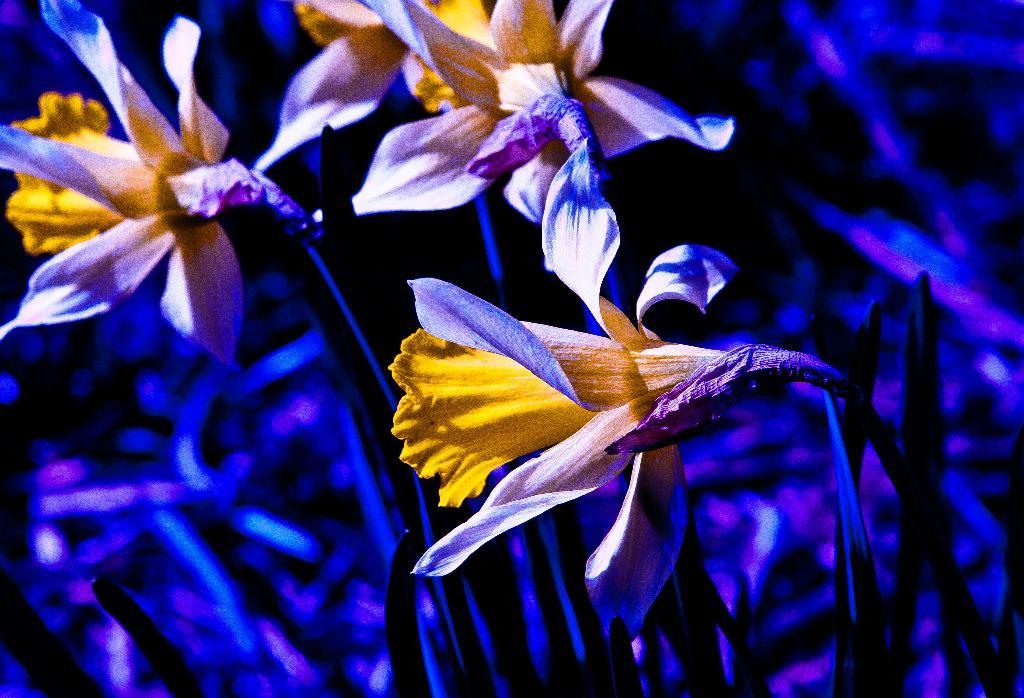What is present in the image? There are flowers in the image. Can you describe the background of the image? The background of the image is blurry. What type of sand can be seen in the image? There is no sand present in the image; it features flowers and a blurry background. How many coils are visible in the image? There are no coils present in the image. 